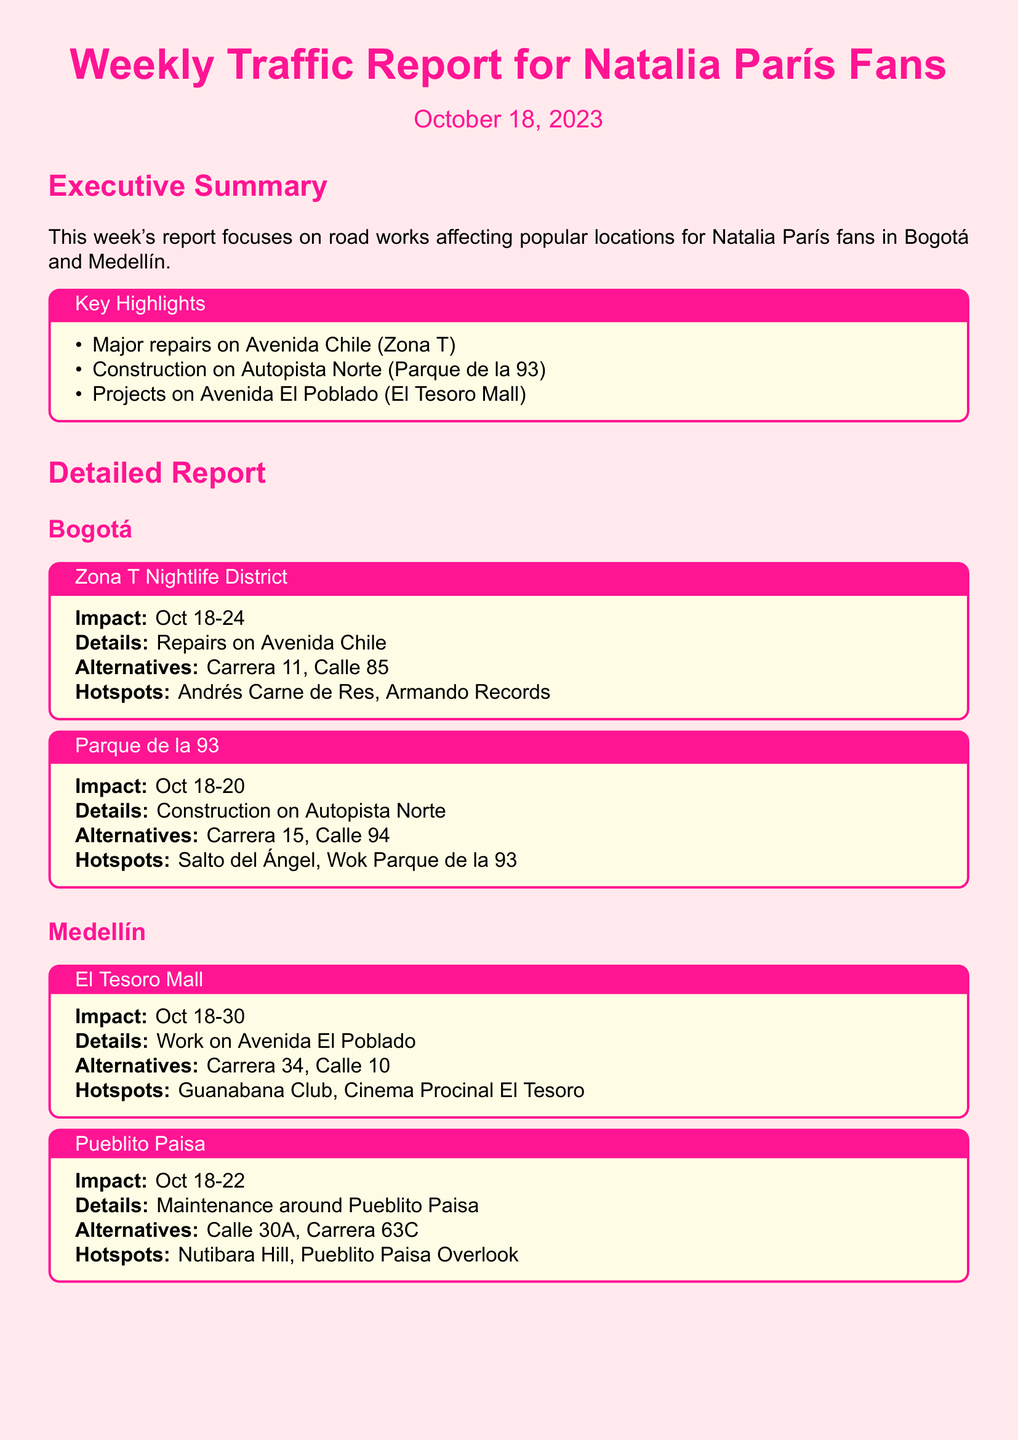What is the impact period for repairs on Avenida Chile? The impact period for repairs on Avenida Chile is specified as Oct 18-24.
Answer: Oct 18-24 What are the alternative routes for Parque de la 93? The alternatives listed for Parque de la 93 are Carrera 15 and Calle 94.
Answer: Carrera 15, Calle 94 Which location in Medellín has construction work from Oct 18-30? The document states that El Tesoro Mall has construction work during that period.
Answer: El Tesoro Mall What are the hotspots near Pueblito Paisa? The hotspots mentioned near Pueblito Paisa are Nutibara Hill and Pueblito Paisa Overlook.
Answer: Nutibara Hill, Pueblito Paisa Overlook Which area experiences construction on Oct 18-20? The area affected by construction during this time is Parque de la 93.
Answer: Parque de la 93 How long is the impact period for repairs in the Zona T Nightlife District? The document indicates that the impact period is from Oct 18 to Oct 24, lasting for 7 days.
Answer: 7 days What is the primary focus of this traffic report? The primary focus of this traffic report is on road works affecting popular locations for Natalia París fans in Bogotá and Medellín.
Answer: Road works affecting popular locations What is the impact start date for maintenance around Pueblito Paisa? The impact start date mentioned for maintenance around Pueblito Paisa is Oct 18.
Answer: Oct 18 